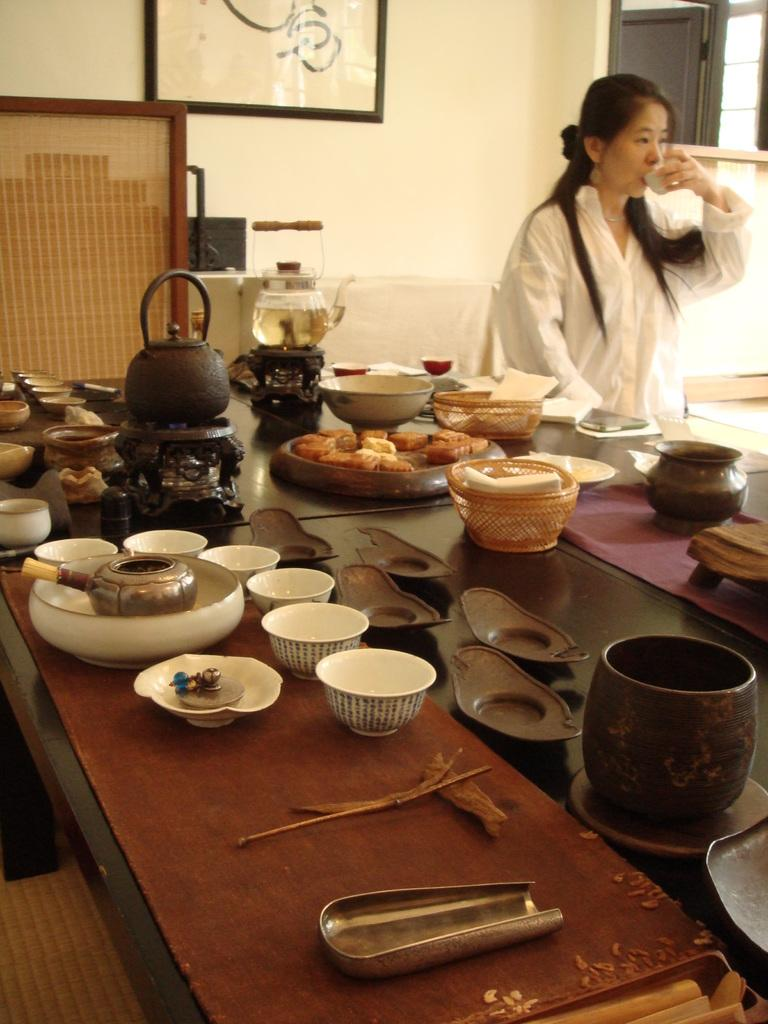Who is present in the image? There is a woman in the image. What is the woman wearing? The woman is wearing a white dress. What can be seen on the table in the image? There are bowls, food, and a jar on the table. What is on the wall in the image? There is a frame on the wall. What type of watch is the woman's father wearing in the image? There is no watch or father present in the image. How can we help the woman with her food in the image? There is no need to help the woman with her food in the image, as it is a still photograph and not a real-life situation. 